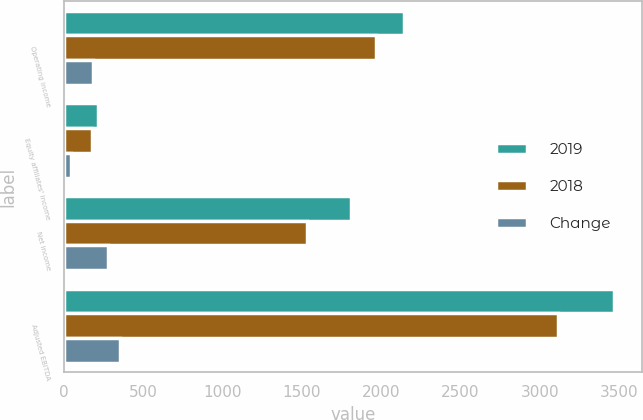Convert chart to OTSL. <chart><loc_0><loc_0><loc_500><loc_500><stacked_bar_chart><ecel><fcel>Operating income<fcel>Equity affiliates' income<fcel>Net income<fcel>Adjusted EBITDA<nl><fcel>2019<fcel>2144.4<fcel>215.4<fcel>1809.4<fcel>3468<nl><fcel>2018<fcel>1965.6<fcel>174.8<fcel>1532.9<fcel>3115.5<nl><fcel>Change<fcel>178.8<fcel>40.6<fcel>276.5<fcel>352.5<nl></chart> 